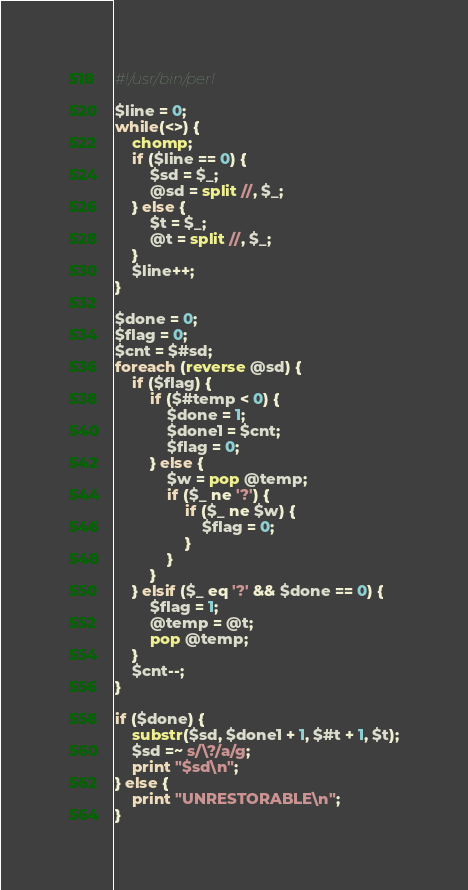<code> <loc_0><loc_0><loc_500><loc_500><_Perl_>#!/usr/bin/perl

$line = 0;
while(<>) {
    chomp;
    if ($line == 0) {
        $sd = $_;
        @sd = split //, $_;
    } else {
        $t = $_;
        @t = split //, $_;
    }
    $line++;
}

$done = 0;
$flag = 0;
$cnt = $#sd;
foreach (reverse @sd) {
    if ($flag) {
        if ($#temp < 0) {
            $done = 1;
            $done1 = $cnt;
            $flag = 0;
        } else {
            $w = pop @temp;
            if ($_ ne '?') {
                if ($_ ne $w) {
                    $flag = 0;
                }
            }
        }
    } elsif ($_ eq '?' && $done == 0) {
        $flag = 1;
        @temp = @t;
        pop @temp;
    }
    $cnt--;
}

if ($done) {
    substr($sd, $done1 + 1, $#t + 1, $t);
    $sd =~ s/\?/a/g;
    print "$sd\n";
} else {
    print "UNRESTORABLE\n";
}
</code> 